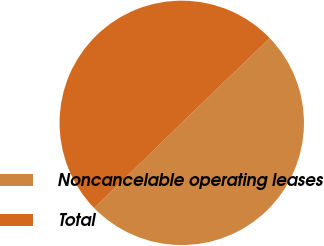Convert chart to OTSL. <chart><loc_0><loc_0><loc_500><loc_500><pie_chart><fcel>Noncancelable operating leases<fcel>Total<nl><fcel>49.93%<fcel>50.07%<nl></chart> 